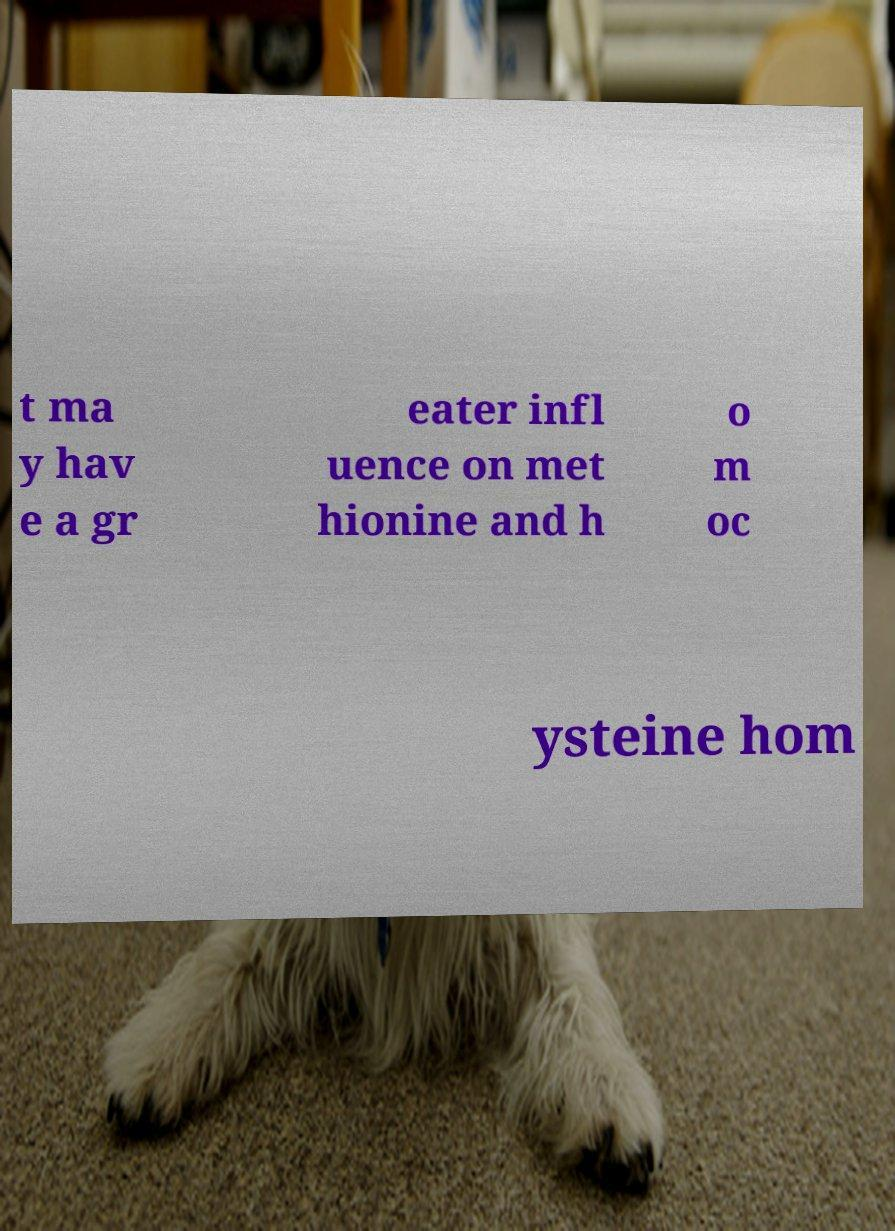For documentation purposes, I need the text within this image transcribed. Could you provide that? t ma y hav e a gr eater infl uence on met hionine and h o m oc ysteine hom 